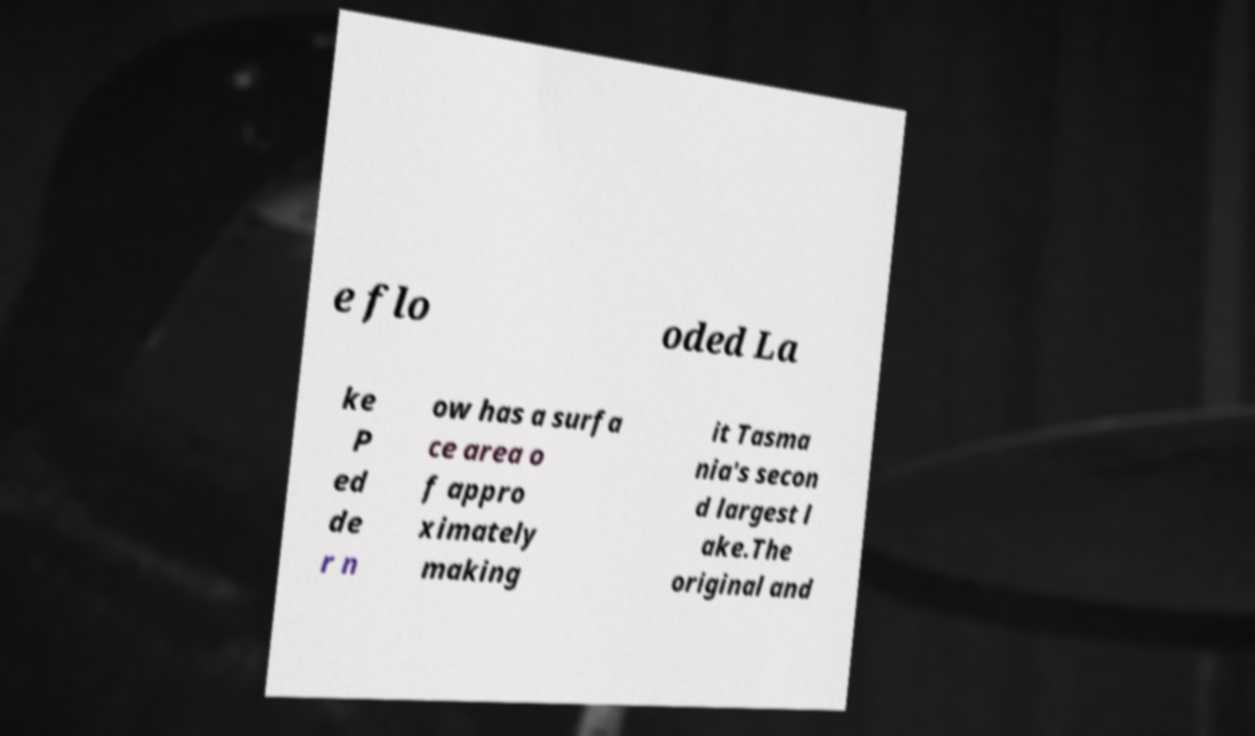There's text embedded in this image that I need extracted. Can you transcribe it verbatim? e flo oded La ke P ed de r n ow has a surfa ce area o f appro ximately making it Tasma nia's secon d largest l ake.The original and 